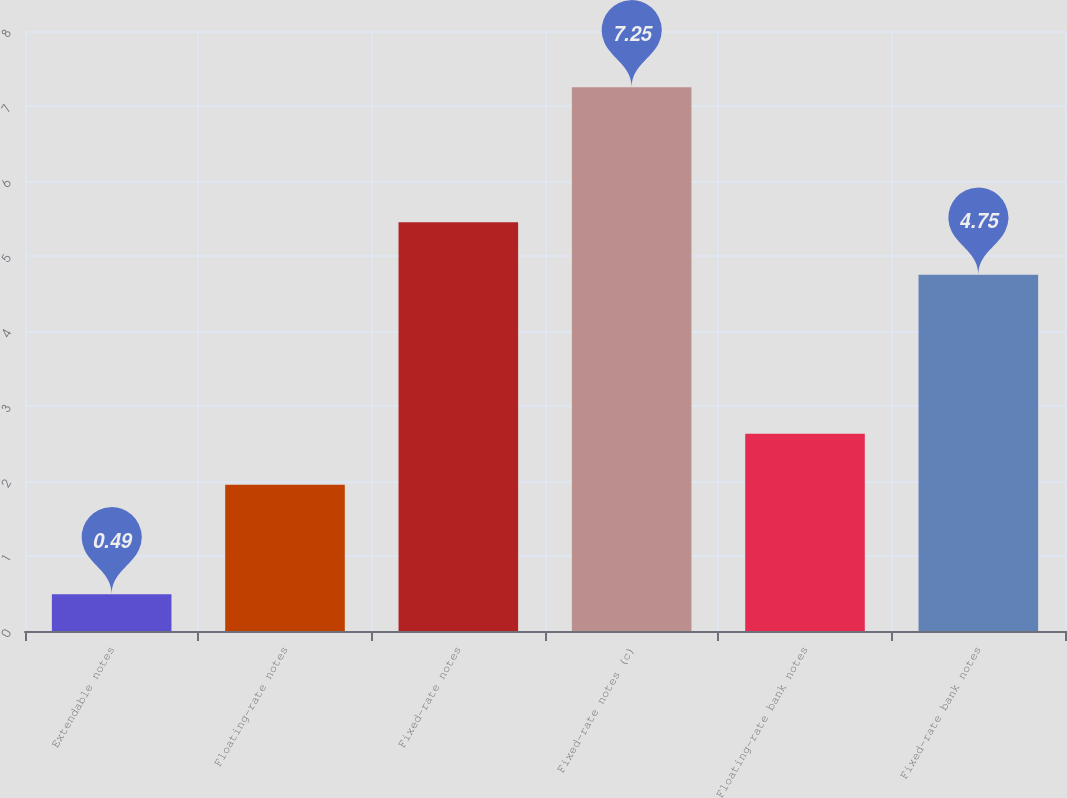Convert chart. <chart><loc_0><loc_0><loc_500><loc_500><bar_chart><fcel>Extendable notes<fcel>Floating-rate notes<fcel>Fixed-rate notes<fcel>Fixed-rate notes (c)<fcel>Floating-rate bank notes<fcel>Fixed-rate bank notes<nl><fcel>0.49<fcel>1.95<fcel>5.45<fcel>7.25<fcel>2.63<fcel>4.75<nl></chart> 